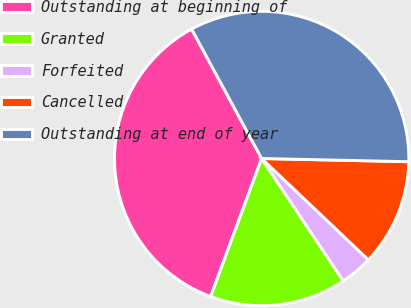Convert chart. <chart><loc_0><loc_0><loc_500><loc_500><pie_chart><fcel>Outstanding at beginning of<fcel>Granted<fcel>Forfeited<fcel>Cancelled<fcel>Outstanding at end of year<nl><fcel>36.48%<fcel>14.98%<fcel>3.56%<fcel>11.74%<fcel>33.24%<nl></chart> 